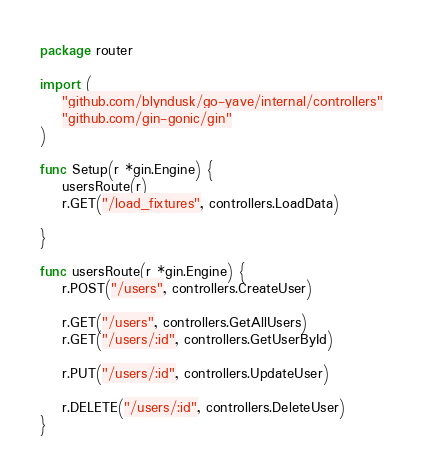<code> <loc_0><loc_0><loc_500><loc_500><_Go_>package router

import (
	"github.com/blyndusk/go-yave/internal/controllers"
	"github.com/gin-gonic/gin"
)

func Setup(r *gin.Engine) {
	usersRoute(r)
	r.GET("/load_fixtures", controllers.LoadData)

}

func usersRoute(r *gin.Engine) {
	r.POST("/users", controllers.CreateUser)

	r.GET("/users", controllers.GetAllUsers)
	r.GET("/users/:id", controllers.GetUserById)

	r.PUT("/users/:id", controllers.UpdateUser)

	r.DELETE("/users/:id", controllers.DeleteUser)
}
</code> 